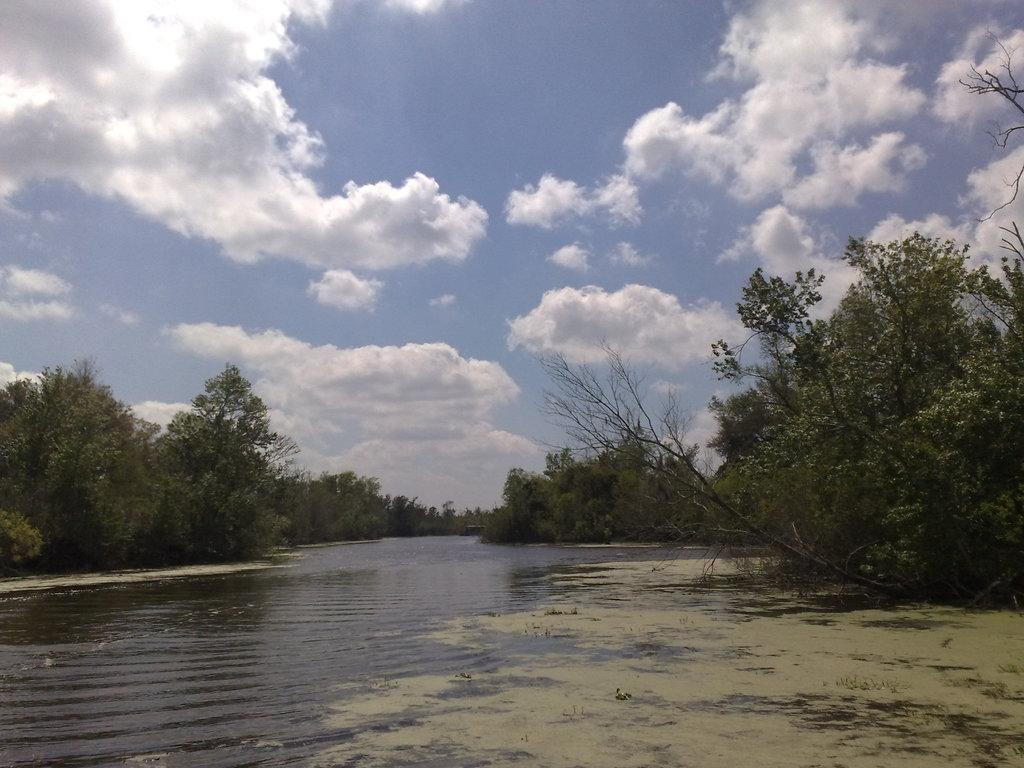What natural feature is the main subject of the image? There is a river in the image. Where is the river located in relation to the image? The river is in the front of the image. What type of vegetation is visible behind the river? There are trees behind the river. What is visible at the top of the image? The sky is visible at the top of the image. What type of silver frame is surrounding the river in the image? There is no silver frame surrounding the river in the image; it is a natural scene with no man-made elements. 